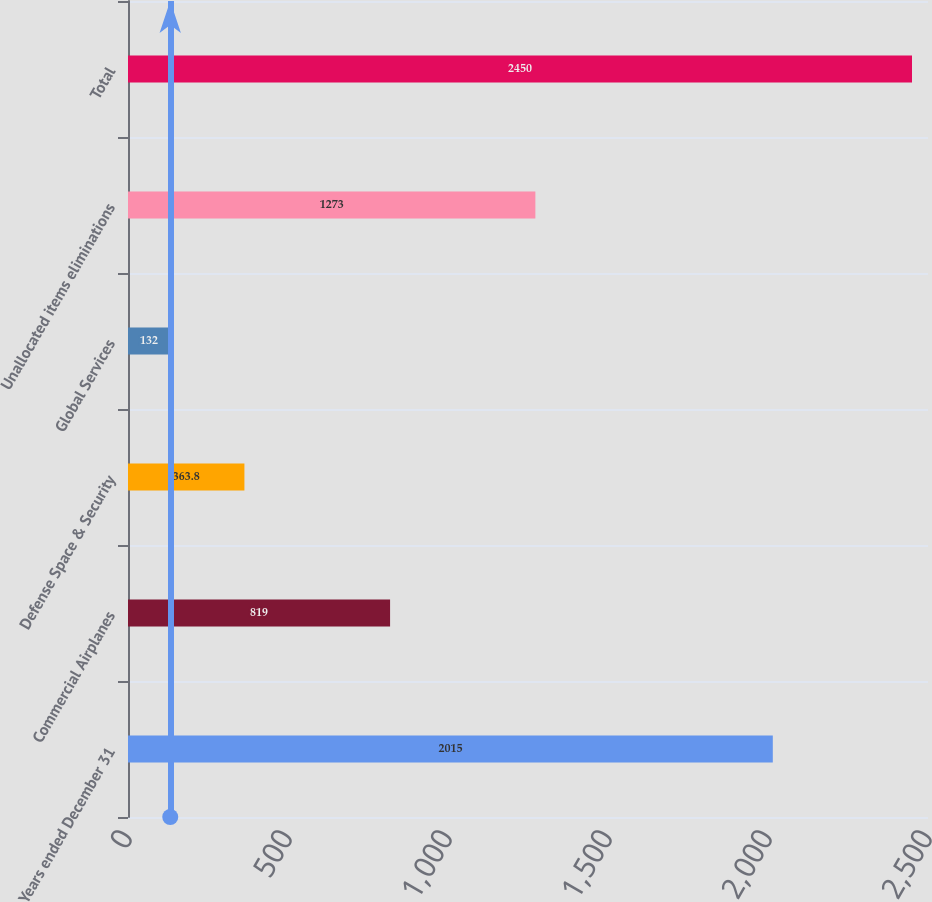Convert chart to OTSL. <chart><loc_0><loc_0><loc_500><loc_500><bar_chart><fcel>Years ended December 31<fcel>Commercial Airplanes<fcel>Defense Space & Security<fcel>Global Services<fcel>Unallocated items eliminations<fcel>Total<nl><fcel>2015<fcel>819<fcel>363.8<fcel>132<fcel>1273<fcel>2450<nl></chart> 